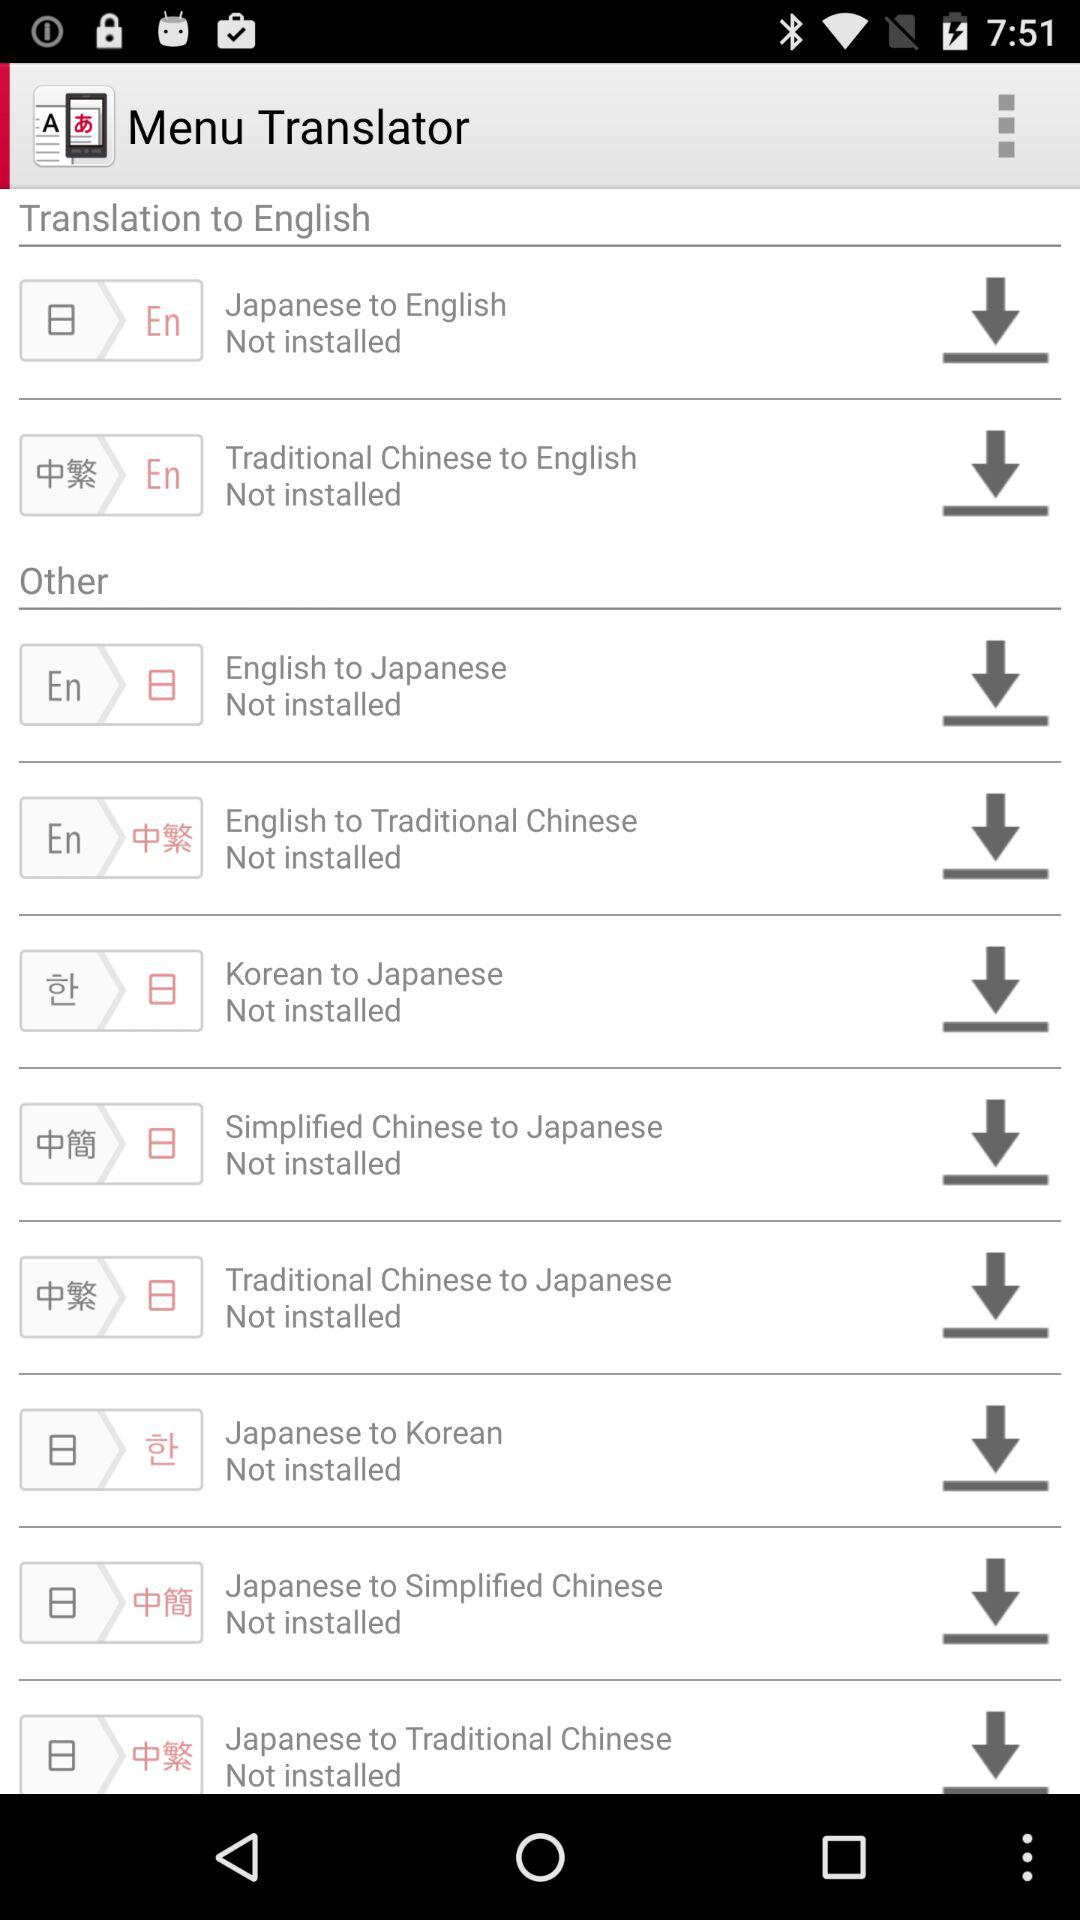Which translator should we install for the Korean language? For the Korean language, you should install "Korean to Japanese" and "Japanese to Korean" translators. 